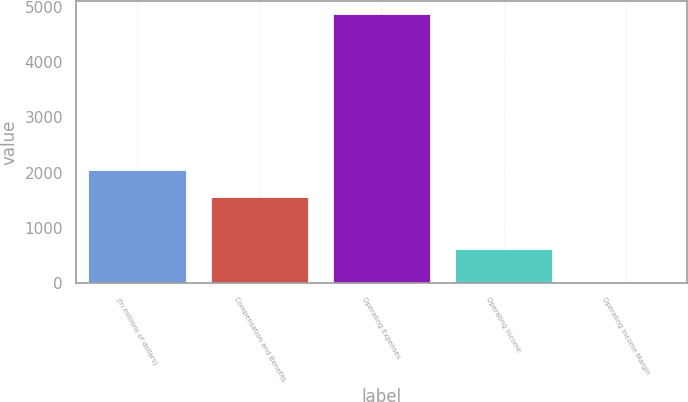<chart> <loc_0><loc_0><loc_500><loc_500><bar_chart><fcel>(In millions of dollars)<fcel>Compensation and Benefits<fcel>Operating Expenses<fcel>Operating Income<fcel>Operating Income Margin<nl><fcel>2040.88<fcel>1555<fcel>4870<fcel>617<fcel>11.2<nl></chart> 